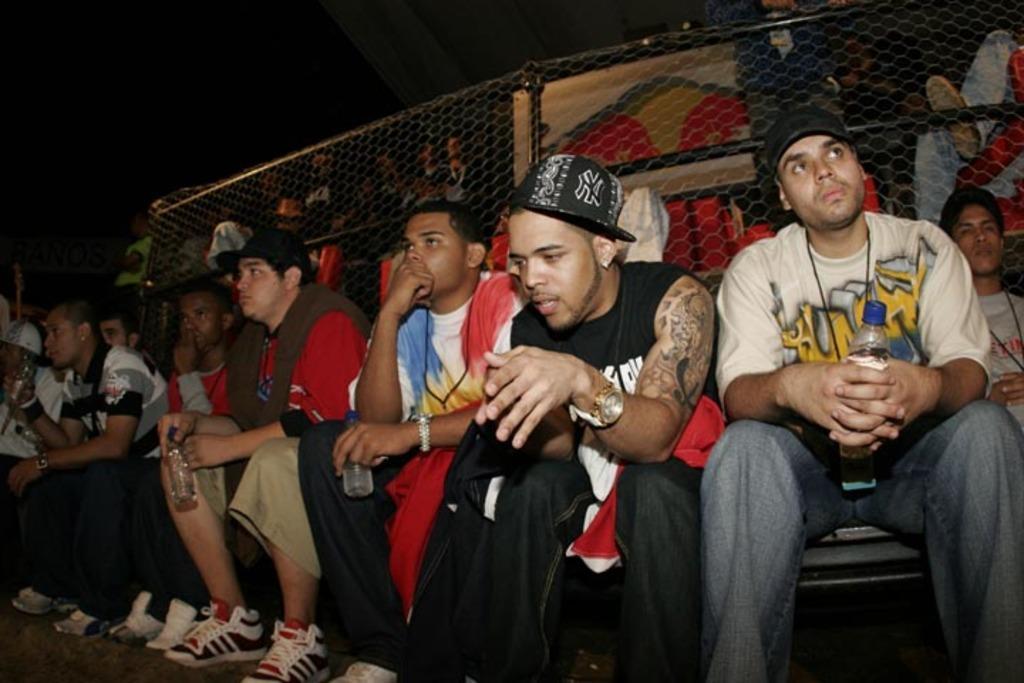Please provide a concise description of this image. In this picture we can see some people sitting in the front, these people wore shoes, a man on the right side is holding a bottle, in the background there is fencing. 